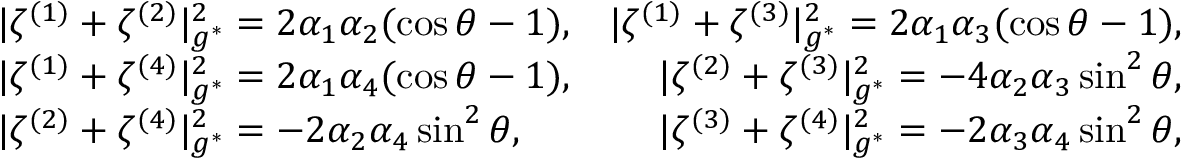<formula> <loc_0><loc_0><loc_500><loc_500>\begin{array} { r l r } & { | \zeta ^ { ( 1 ) } + \zeta ^ { ( 2 ) } | _ { g ^ { * } } ^ { 2 } = 2 \alpha _ { 1 } \alpha _ { 2 } ( \cos \theta - 1 ) , } & { | \zeta ^ { ( 1 ) } + \zeta ^ { ( 3 ) } | _ { g ^ { * } } ^ { 2 } = 2 \alpha _ { 1 } \alpha _ { 3 } ( \cos \theta - 1 ) , } \\ & { | \zeta ^ { ( 1 ) } + \zeta ^ { ( 4 ) } | _ { g ^ { * } } ^ { 2 } = 2 \alpha _ { 1 } \alpha _ { 4 } ( \cos \theta - 1 ) , } & { | \zeta ^ { ( 2 ) } + \zeta ^ { ( 3 ) } | _ { g ^ { * } } ^ { 2 } = - 4 \alpha _ { 2 } \alpha _ { 3 } \sin ^ { 2 } \theta , } \\ & { | \zeta ^ { ( 2 ) } + \zeta ^ { ( 4 ) } | _ { g ^ { * } } ^ { 2 } = - 2 \alpha _ { 2 } \alpha _ { 4 } \sin ^ { 2 } \theta , } & { | \zeta ^ { ( 3 ) } + \zeta ^ { ( 4 ) } | _ { g ^ { * } } ^ { 2 } = - 2 \alpha _ { 3 } \alpha _ { 4 } \sin ^ { 2 } \theta , } \end{array}</formula> 